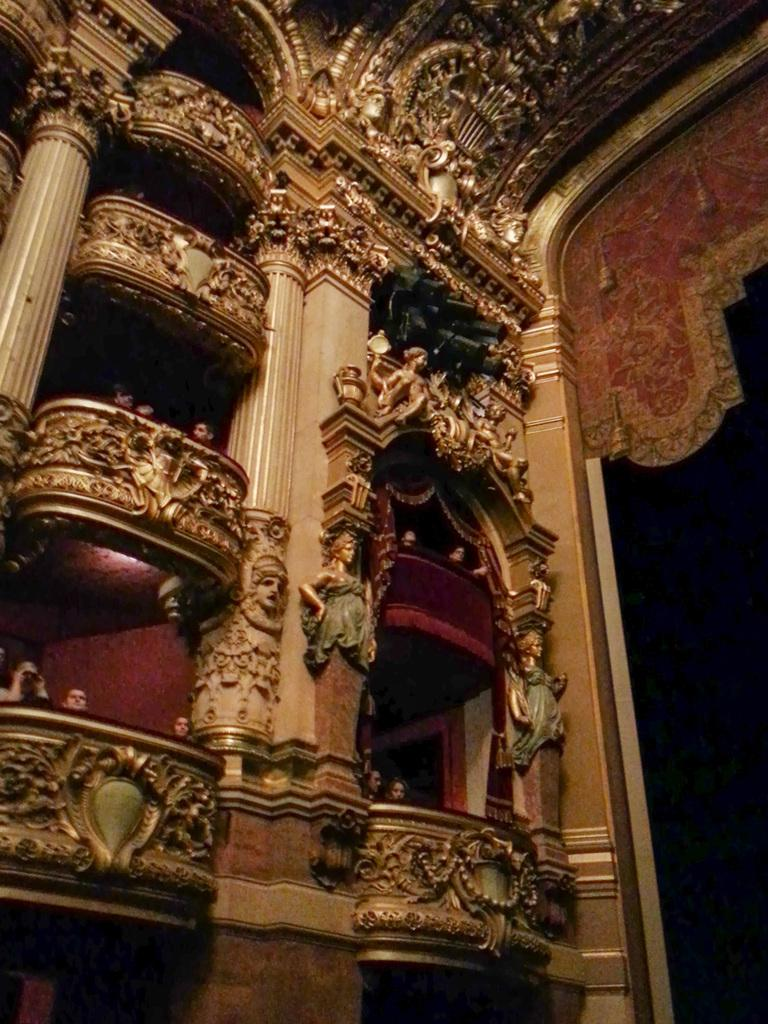What type of location is depicted in the image? The image shows an inside view of a building. What are the people in the image doing? There is a group of people sitting in the building. What architectural features can be seen in the building? There are statues, pillars, and dome lights visible in the building. What type of window treatment is present in the image? There is a curtain in the background of the image. How does the building react to the earthquake in the image? There is no earthquake present in the image; it shows a group of people sitting in a building with various architectural features. What type of park can be seen in the background of the image? There is no park visible in the image; it shows an inside view of a building with a curtain in the background. 